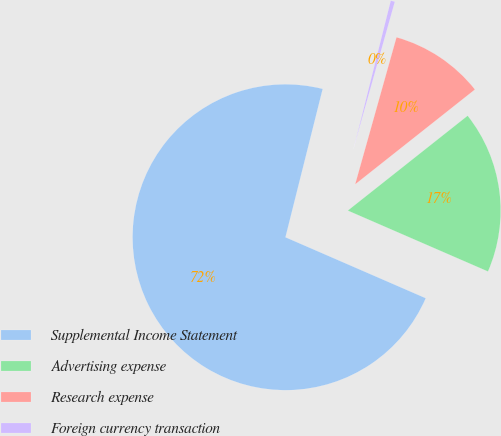Convert chart. <chart><loc_0><loc_0><loc_500><loc_500><pie_chart><fcel>Supplemental Income Statement<fcel>Advertising expense<fcel>Research expense<fcel>Foreign currency transaction<nl><fcel>72.39%<fcel>17.18%<fcel>9.98%<fcel>0.45%<nl></chart> 